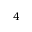<formula> <loc_0><loc_0><loc_500><loc_500>4</formula> 